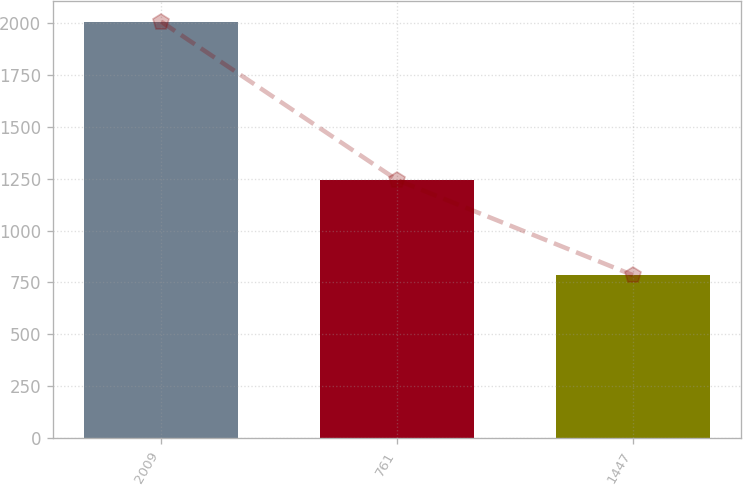Convert chart. <chart><loc_0><loc_0><loc_500><loc_500><bar_chart><fcel>2009<fcel>761<fcel>1447<nl><fcel>2007<fcel>1244<fcel>785<nl></chart> 